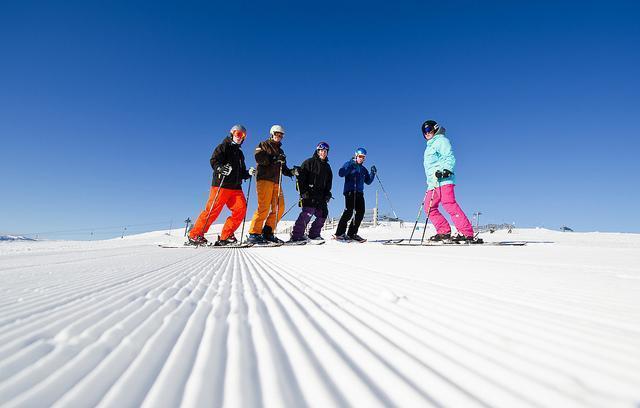How many people are wearing black pants?
Give a very brief answer. 2. How many people can be seen?
Give a very brief answer. 4. How many tracks have a train on them?
Give a very brief answer. 0. 